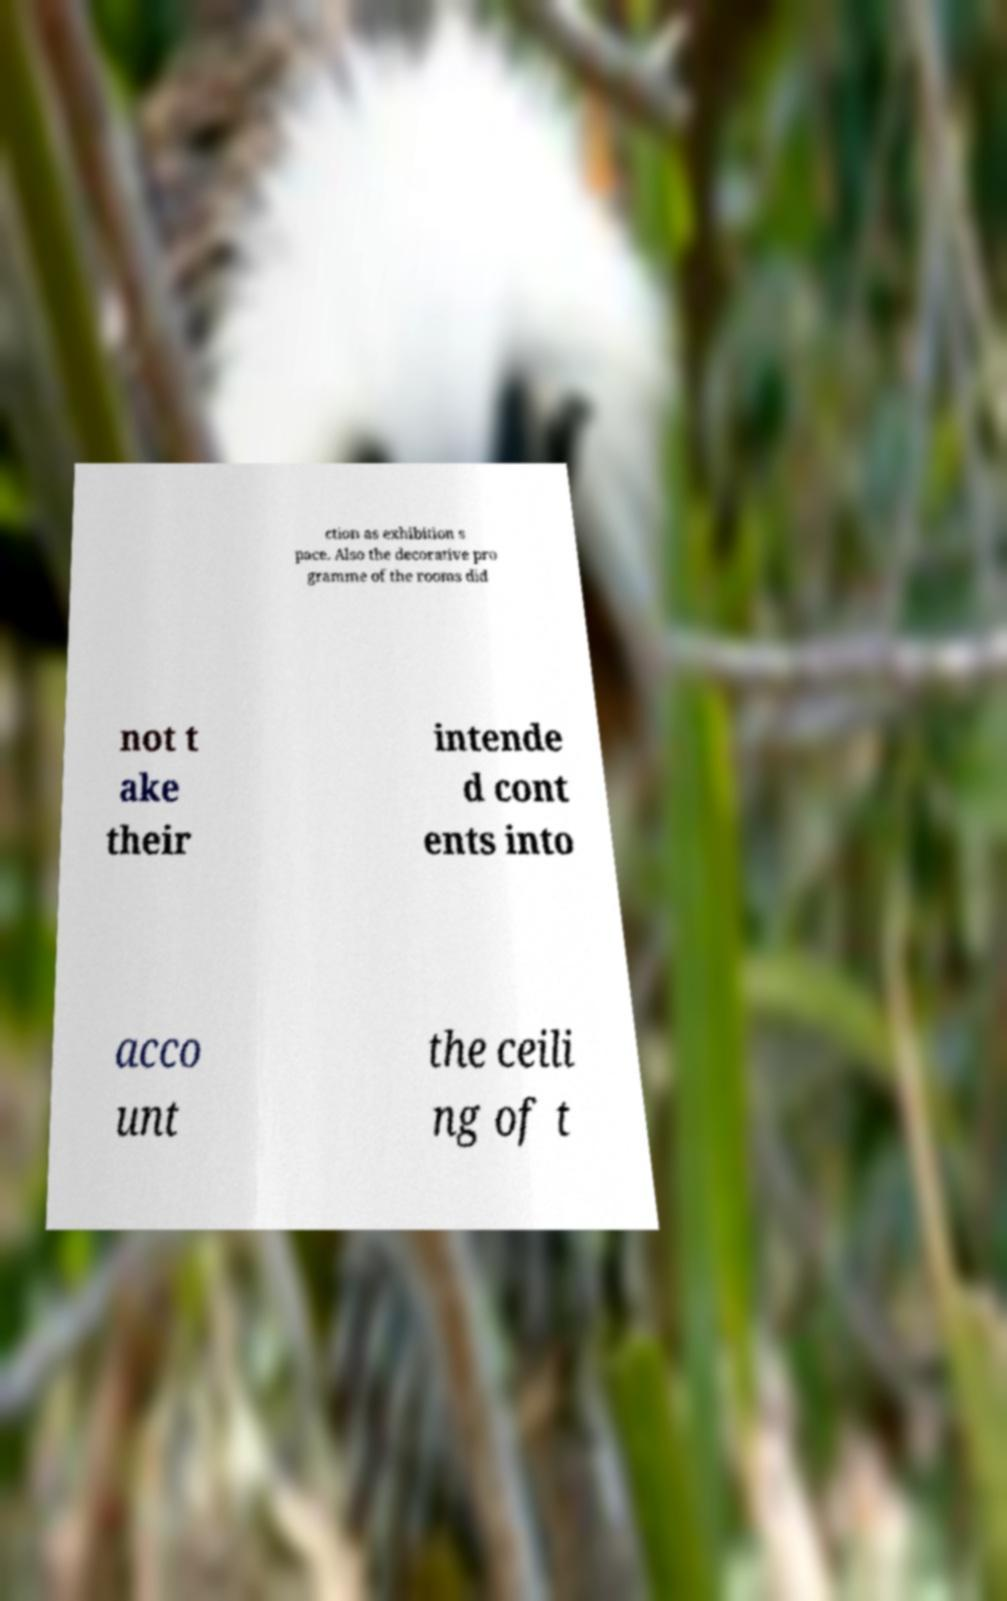What messages or text are displayed in this image? I need them in a readable, typed format. ction as exhibition s pace. Also the decorative pro gramme of the rooms did not t ake their intende d cont ents into acco unt the ceili ng of t 